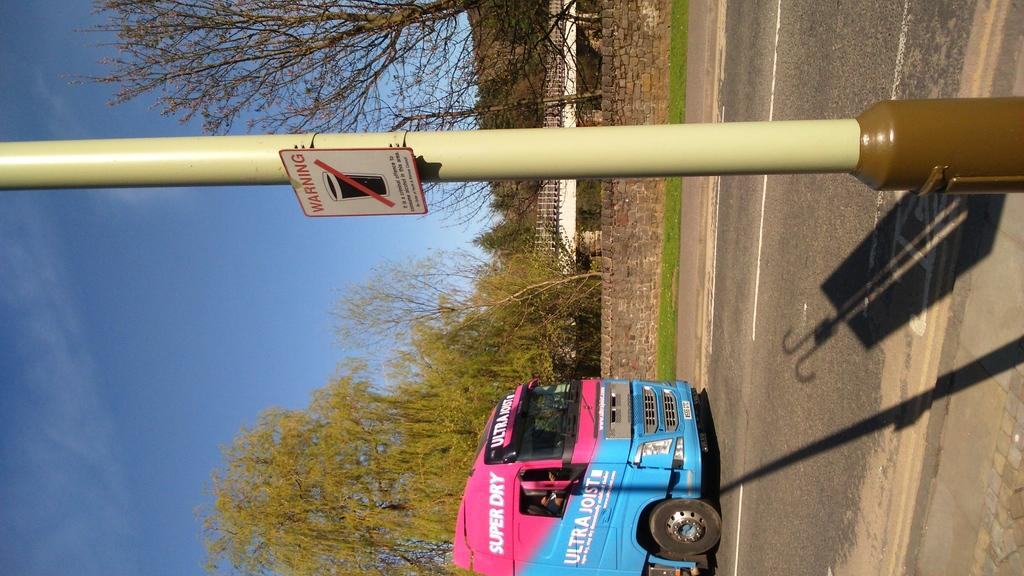<image>
Relay a brief, clear account of the picture shown. A pink and blue colored bus says super dry in white letters. 